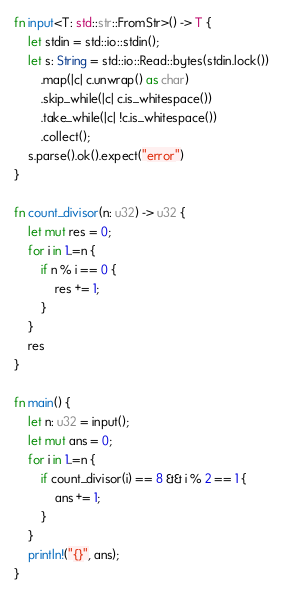Convert code to text. <code><loc_0><loc_0><loc_500><loc_500><_Rust_>fn input<T: std::str::FromStr>() -> T {
    let stdin = std::io::stdin();
    let s: String = std::io::Read::bytes(stdin.lock())
        .map(|c| c.unwrap() as char)
        .skip_while(|c| c.is_whitespace())
        .take_while(|c| !c.is_whitespace())
        .collect();
    s.parse().ok().expect("error")
}

fn count_divisor(n: u32) -> u32 {
    let mut res = 0;
    for i in 1..=n {
        if n % i == 0 {
            res += 1;
        }
    }
    res
}

fn main() {
    let n: u32 = input();
    let mut ans = 0;
    for i in 1..=n {
        if count_divisor(i) == 8 && i % 2 == 1 {
            ans += 1;
        }
    }
    println!("{}", ans);
}</code> 